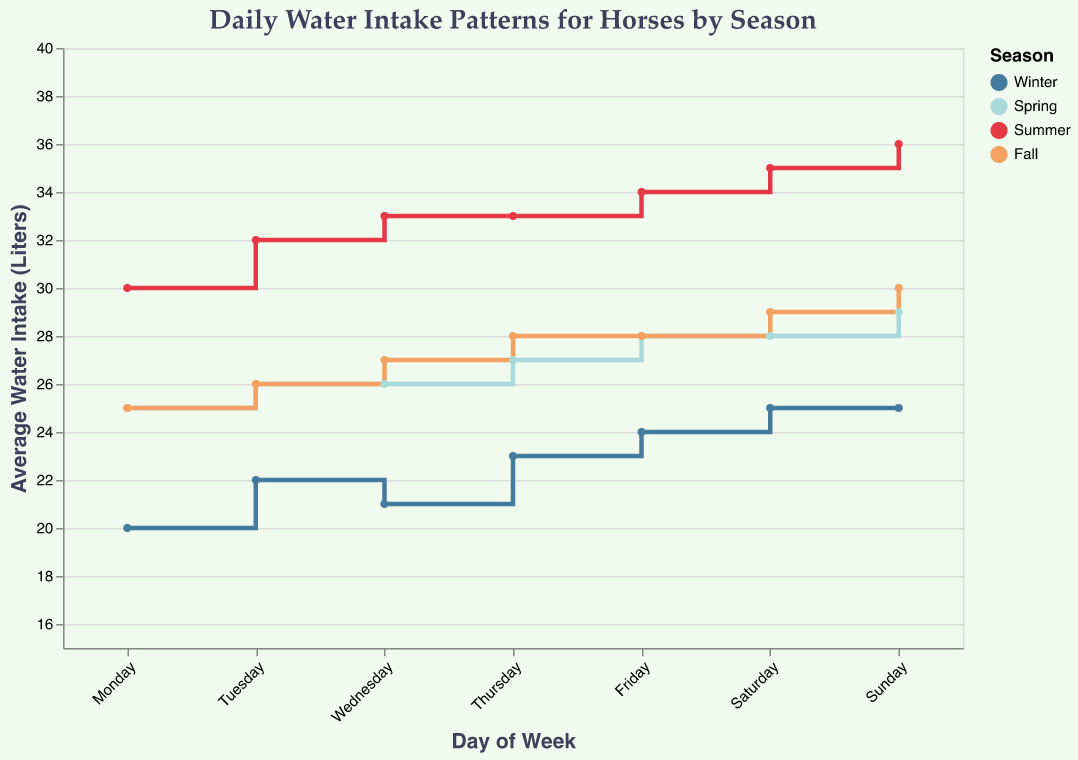What is the title of the plot? The title is usually positioned at the top of the plot and specifies what the visualized data is about. In this case, it indicates the subject of the stair plot.
Answer: Daily Water Intake Patterns for Horses by Season How is the average water intake on Wednesdays in Winter compared to Spring? Find the intake for Wednesdays in Winter and Spring from the plot or data table. Winter shows 21 liters, Spring shows 26 liters. The comparison indicates that Spring has a higher water intake on Wednesdays.
Answer: Spring has a higher water intake on Wednesdays Which season has the highest average water intake on Sundays? Look for the Sunday data points across all seasons in the plot. Summer has the highest value, at 36 liters.
Answer: Summer What is the average water intake on Fridays in Fall and Spring? Check the Fridays' values for Fall and Spring from the data. Fall is 28 liters and Spring is 28 liters. There is no difference in values.
Answer: 28 liters By how many liters does the average water intake on Mondays increase from Winter to Summer? Monday's values for Winter (20 liters) and Summer (30 liters). Subtract Winter's value from Summer's value: 30 - 20 = 10 liters increase.
Answer: 10 liters Which two consecutive days in Summer have the largest increase in average water intake? Review the Summer values sequentially. The largest increase happens from Monday (30 liters) to Tuesday (32 liters), which is an increase of 2 liters.
Answer: Monday to Tuesday Does the average water intake stay constant on any day of the week in any season? Check each day of the week within each season to see if any have constant values. In Winter, the intake stays constant at 25 liters from Saturday to Sunday.
Answer: Yes, in Winter, from Saturday to Sunday 